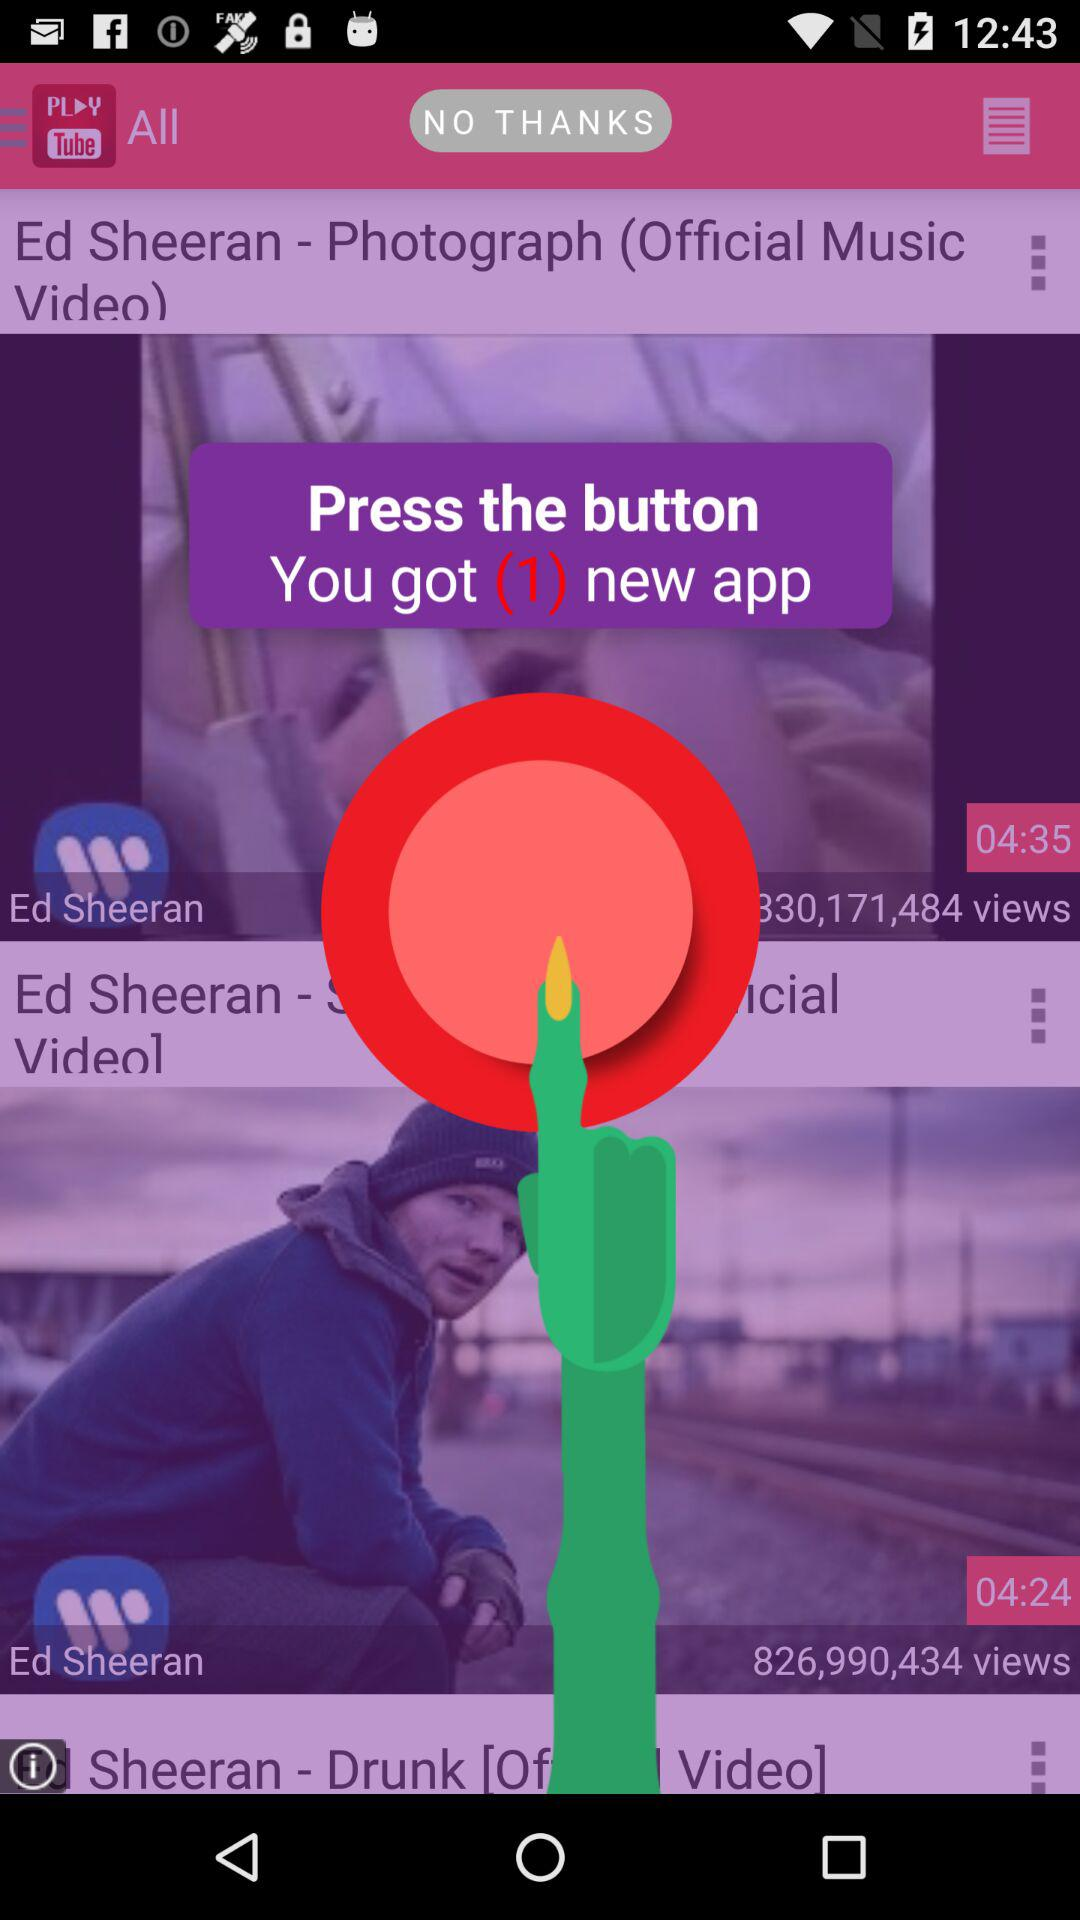How many more seconds long is the video with the title 'Ed Sheeran - Drunk [Official Music Video]' than the video with the title 'Ed Sheeran - Photograph (Official Music Video)'?
Answer the question using a single word or phrase. 11 